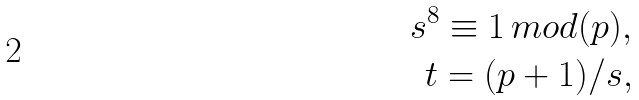Convert formula to latex. <formula><loc_0><loc_0><loc_500><loc_500>s ^ { 8 } \equiv 1 \, m o d ( p ) , \\ t = ( p + 1 ) / s ,</formula> 